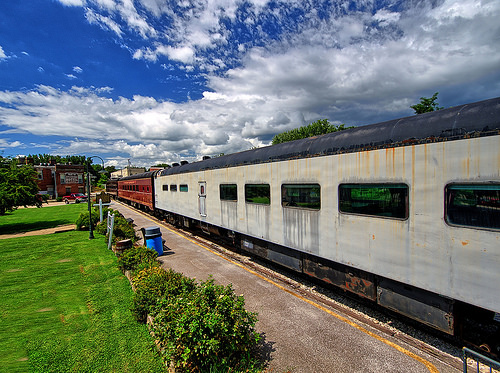<image>
Is the building behind the train? Yes. From this viewpoint, the building is positioned behind the train, with the train partially or fully occluding the building. Is there a trash can next to the train? Yes. The trash can is positioned adjacent to the train, located nearby in the same general area. Where is the bushes in relation to the train? Is it next to the train? Yes. The bushes is positioned adjacent to the train, located nearby in the same general area. 